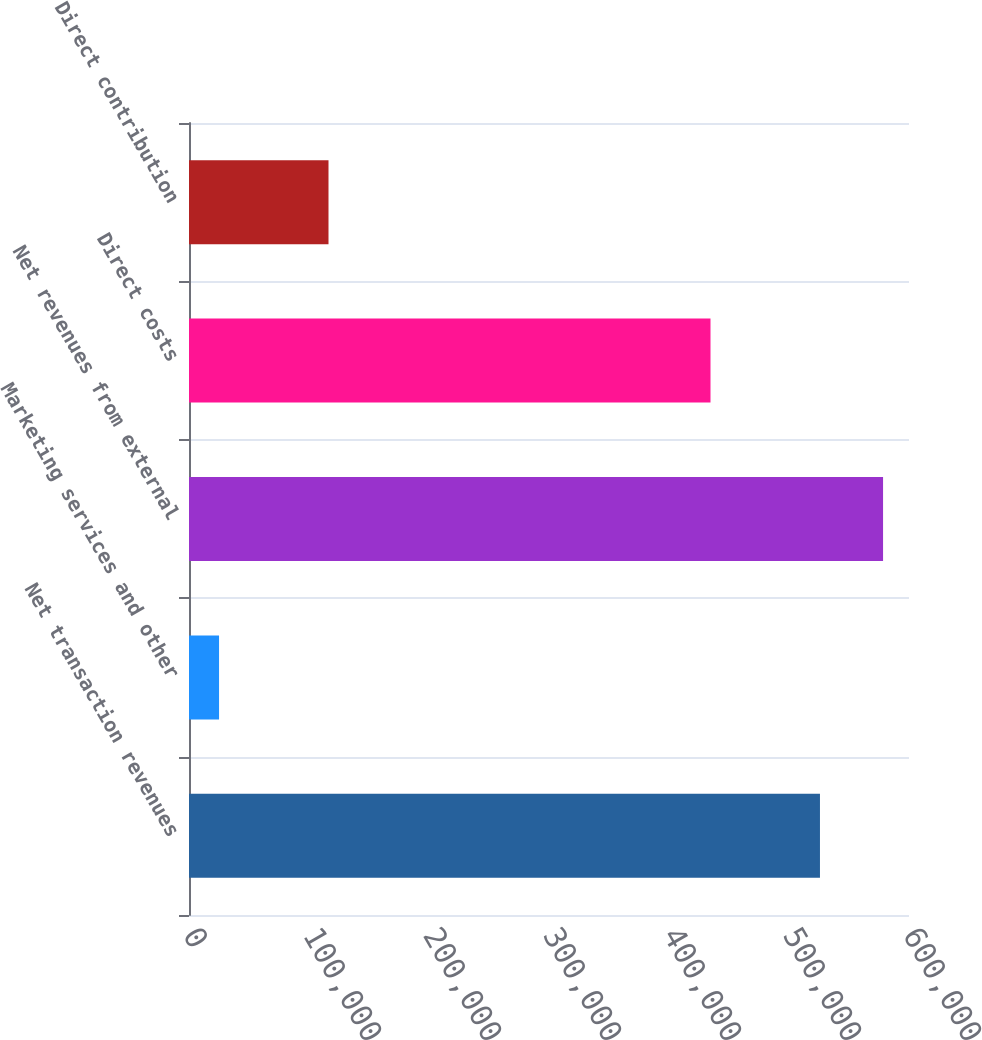Convert chart. <chart><loc_0><loc_0><loc_500><loc_500><bar_chart><fcel>Net transaction revenues<fcel>Marketing services and other<fcel>Net revenues from external<fcel>Direct costs<fcel>Direct contribution<nl><fcel>525803<fcel>25038<fcel>578383<fcel>434588<fcel>116253<nl></chart> 